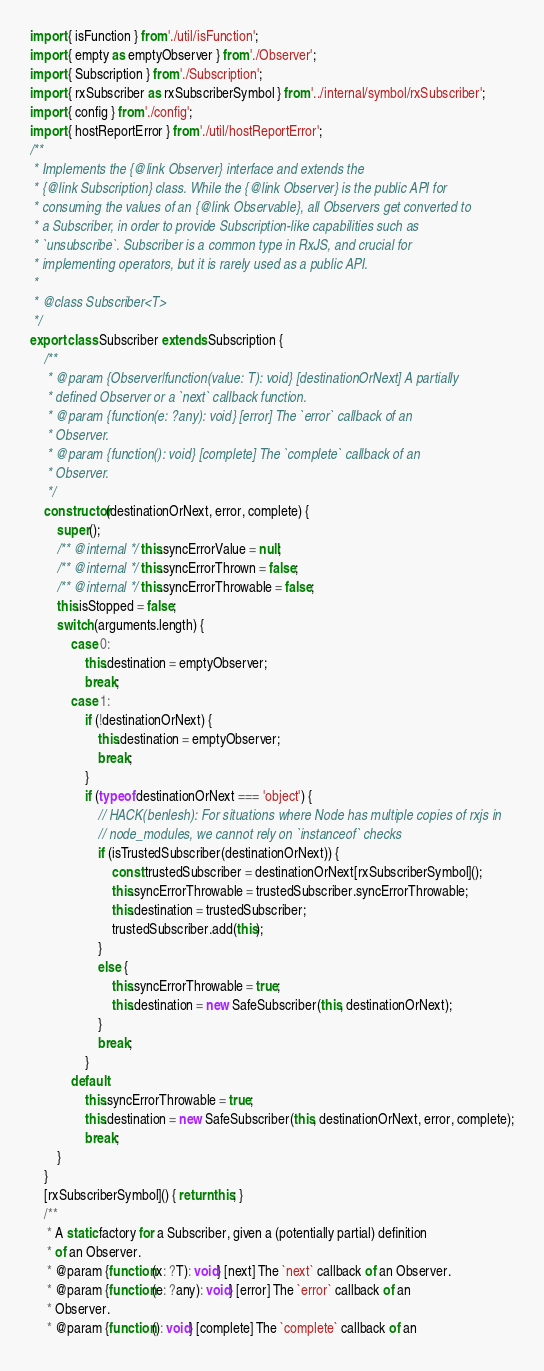Convert code to text. <code><loc_0><loc_0><loc_500><loc_500><_JavaScript_>import { isFunction } from './util/isFunction';
import { empty as emptyObserver } from './Observer';
import { Subscription } from './Subscription';
import { rxSubscriber as rxSubscriberSymbol } from '../internal/symbol/rxSubscriber';
import { config } from './config';
import { hostReportError } from './util/hostReportError';
/**
 * Implements the {@link Observer} interface and extends the
 * {@link Subscription} class. While the {@link Observer} is the public API for
 * consuming the values of an {@link Observable}, all Observers get converted to
 * a Subscriber, in order to provide Subscription-like capabilities such as
 * `unsubscribe`. Subscriber is a common type in RxJS, and crucial for
 * implementing operators, but it is rarely used as a public API.
 *
 * @class Subscriber<T>
 */
export class Subscriber extends Subscription {
    /**
     * @param {Observer|function(value: T): void} [destinationOrNext] A partially
     * defined Observer or a `next` callback function.
     * @param {function(e: ?any): void} [error] The `error` callback of an
     * Observer.
     * @param {function(): void} [complete] The `complete` callback of an
     * Observer.
     */
    constructor(destinationOrNext, error, complete) {
        super();
        /** @internal */ this.syncErrorValue = null;
        /** @internal */ this.syncErrorThrown = false;
        /** @internal */ this.syncErrorThrowable = false;
        this.isStopped = false;
        switch (arguments.length) {
            case 0:
                this.destination = emptyObserver;
                break;
            case 1:
                if (!destinationOrNext) {
                    this.destination = emptyObserver;
                    break;
                }
                if (typeof destinationOrNext === 'object') {
                    // HACK(benlesh): For situations where Node has multiple copies of rxjs in
                    // node_modules, we cannot rely on `instanceof` checks
                    if (isTrustedSubscriber(destinationOrNext)) {
                        const trustedSubscriber = destinationOrNext[rxSubscriberSymbol]();
                        this.syncErrorThrowable = trustedSubscriber.syncErrorThrowable;
                        this.destination = trustedSubscriber;
                        trustedSubscriber.add(this);
                    }
                    else {
                        this.syncErrorThrowable = true;
                        this.destination = new SafeSubscriber(this, destinationOrNext);
                    }
                    break;
                }
            default:
                this.syncErrorThrowable = true;
                this.destination = new SafeSubscriber(this, destinationOrNext, error, complete);
                break;
        }
    }
    [rxSubscriberSymbol]() { return this; }
    /**
     * A static factory for a Subscriber, given a (potentially partial) definition
     * of an Observer.
     * @param {function(x: ?T): void} [next] The `next` callback of an Observer.
     * @param {function(e: ?any): void} [error] The `error` callback of an
     * Observer.
     * @param {function(): void} [complete] The `complete` callback of an</code> 